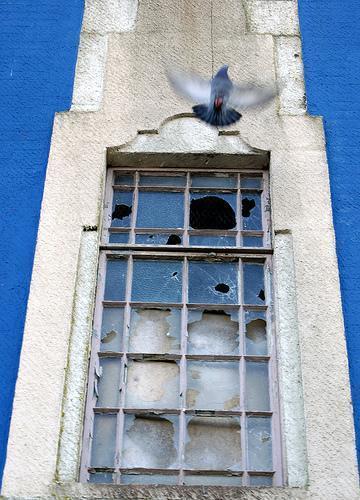How many birds are there?
Give a very brief answer. 1. How many square window pains are not broken?
Give a very brief answer. 1. 